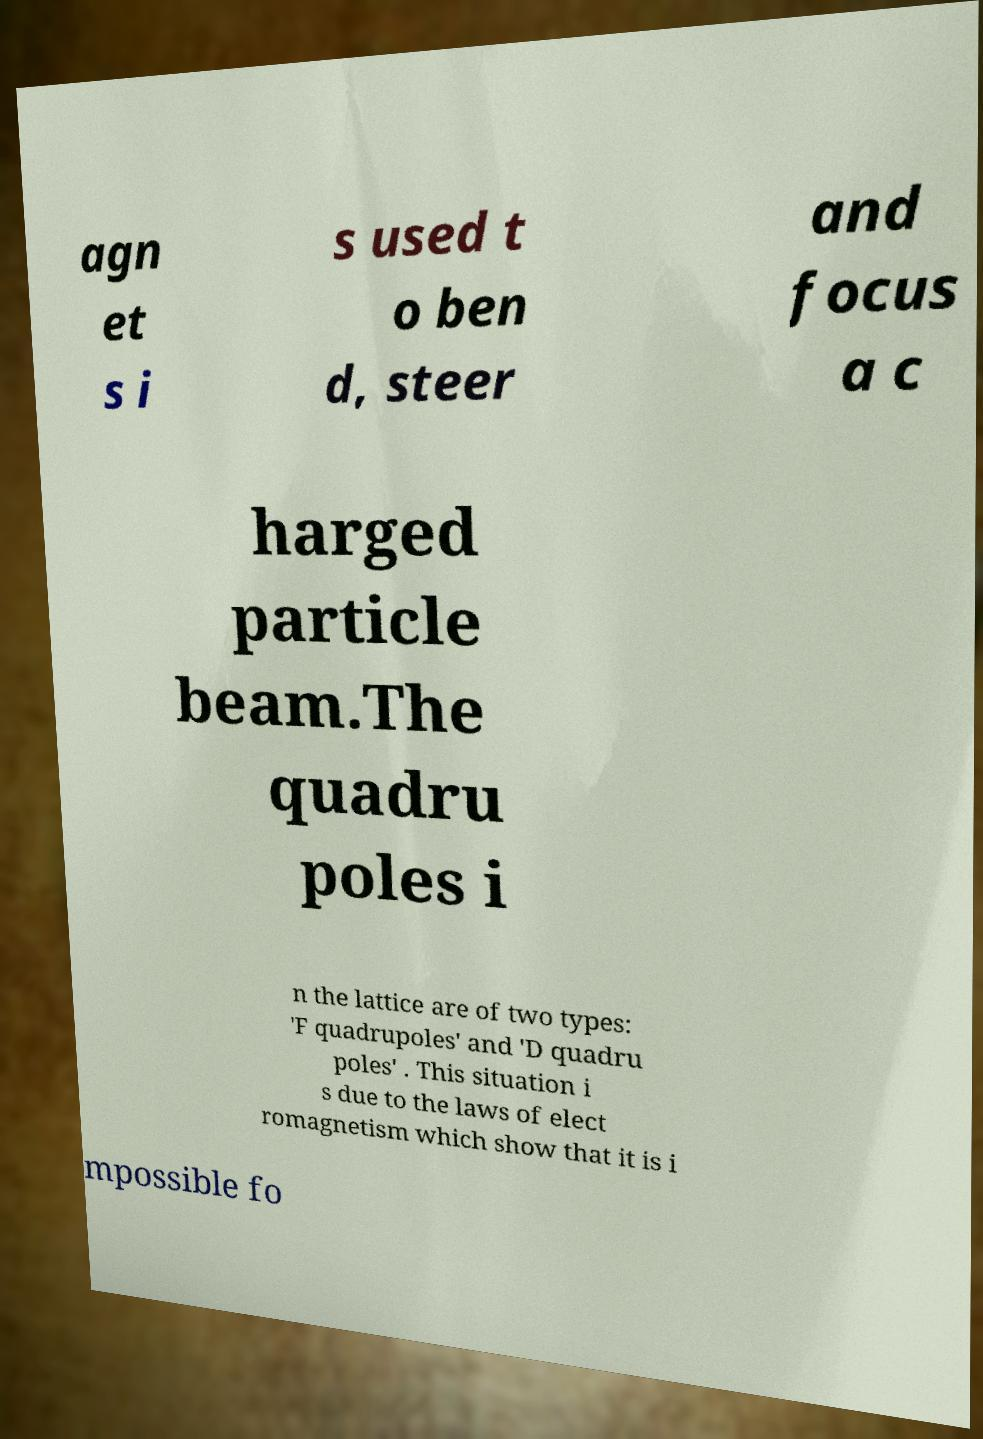There's text embedded in this image that I need extracted. Can you transcribe it verbatim? agn et s i s used t o ben d, steer and focus a c harged particle beam.The quadru poles i n the lattice are of two types: 'F quadrupoles' and 'D quadru poles' . This situation i s due to the laws of elect romagnetism which show that it is i mpossible fo 